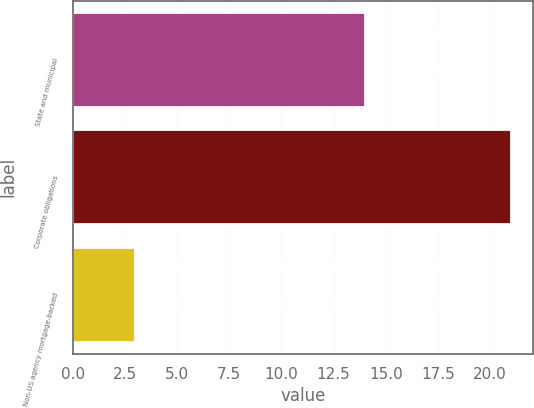Convert chart. <chart><loc_0><loc_0><loc_500><loc_500><bar_chart><fcel>State and municipal<fcel>Corporate obligations<fcel>Non-US agency mortgage-backed<nl><fcel>14<fcel>21<fcel>3<nl></chart> 